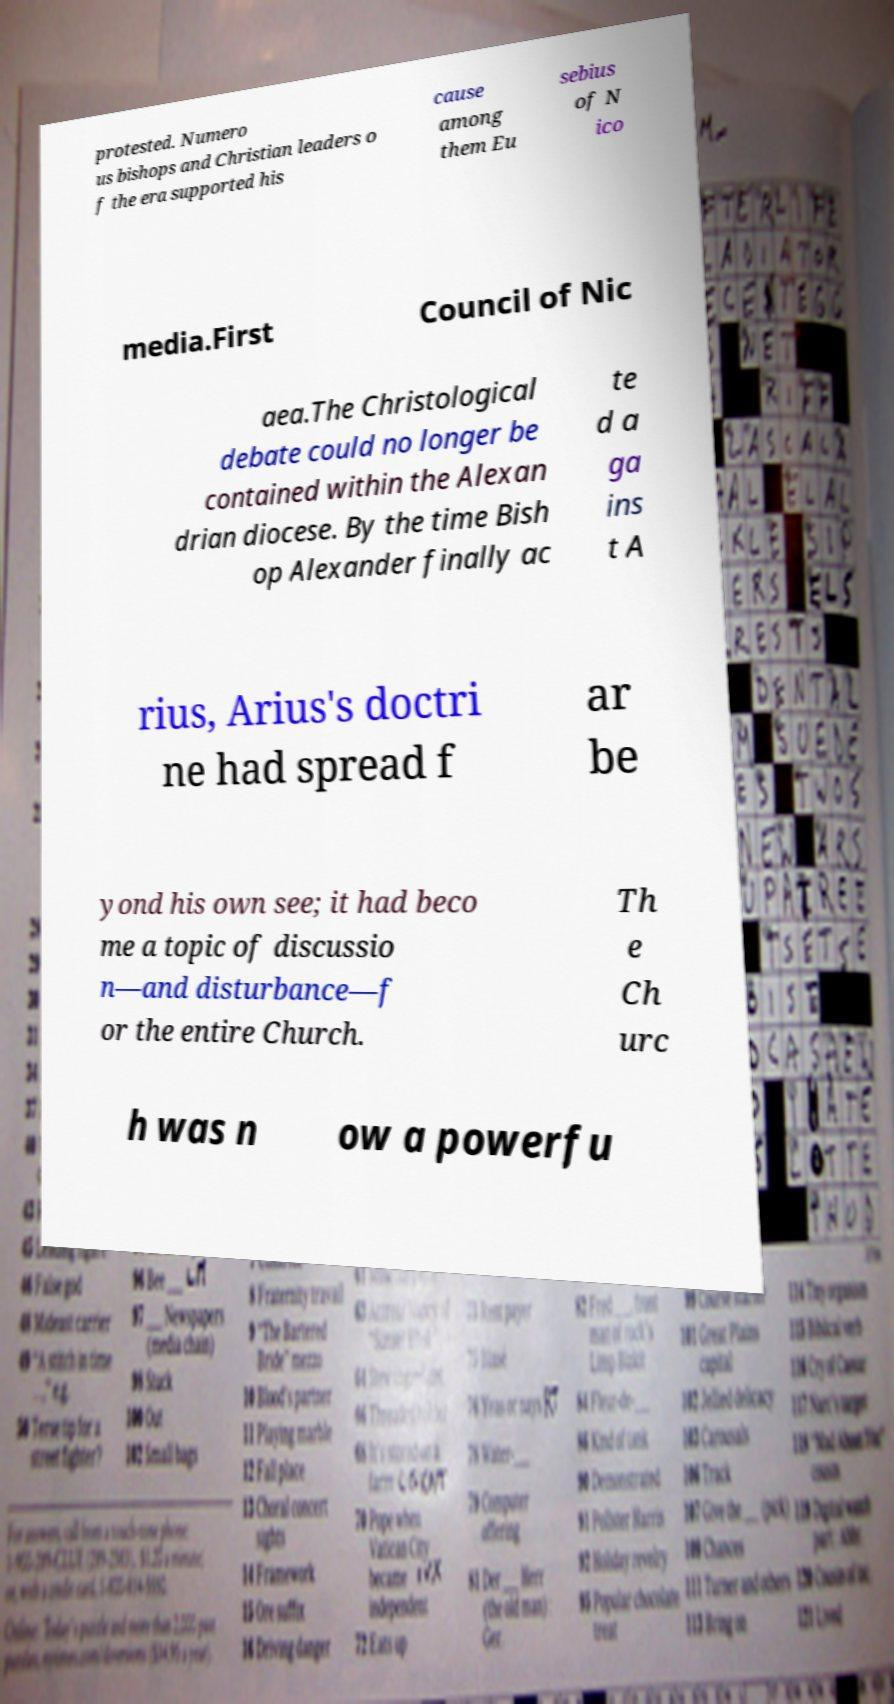I need the written content from this picture converted into text. Can you do that? protested. Numero us bishops and Christian leaders o f the era supported his cause among them Eu sebius of N ico media.First Council of Nic aea.The Christological debate could no longer be contained within the Alexan drian diocese. By the time Bish op Alexander finally ac te d a ga ins t A rius, Arius's doctri ne had spread f ar be yond his own see; it had beco me a topic of discussio n—and disturbance—f or the entire Church. Th e Ch urc h was n ow a powerfu 